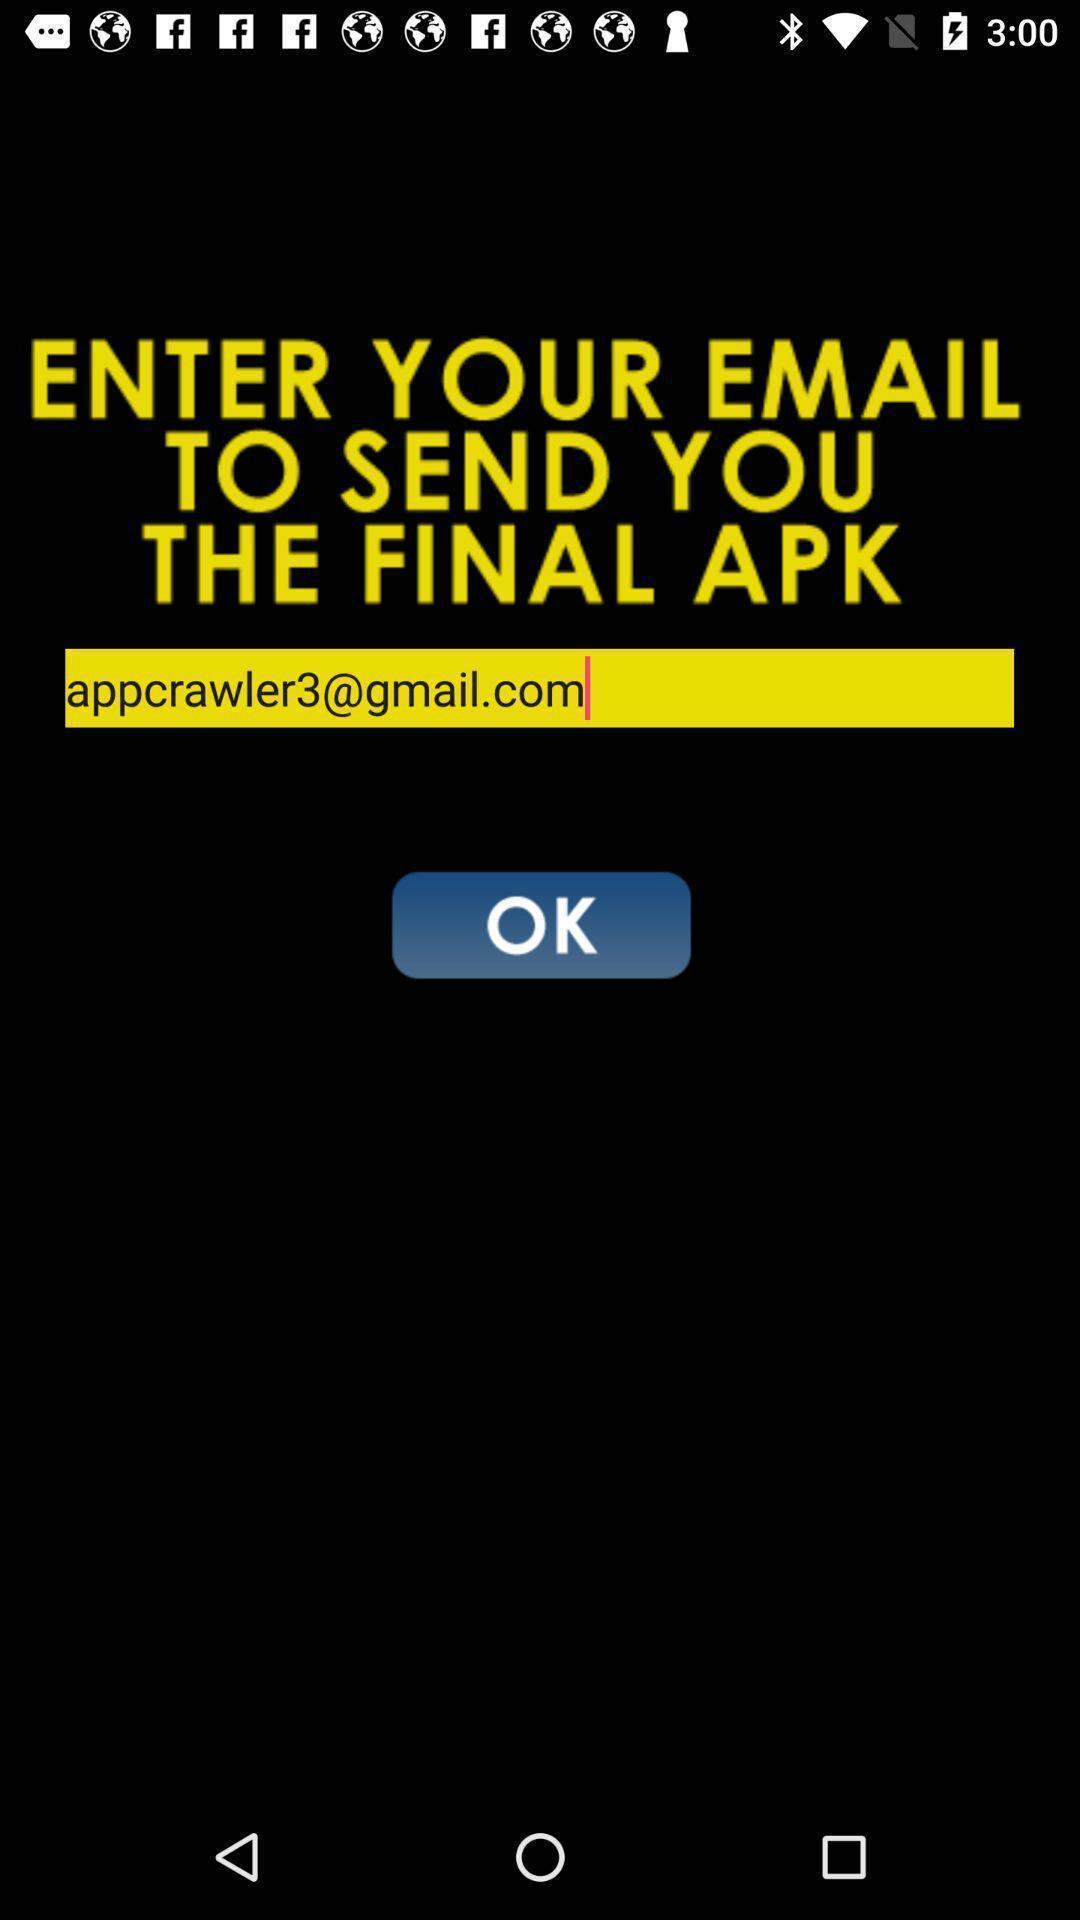Provide a textual representation of this image. Page to enter email in the application. 